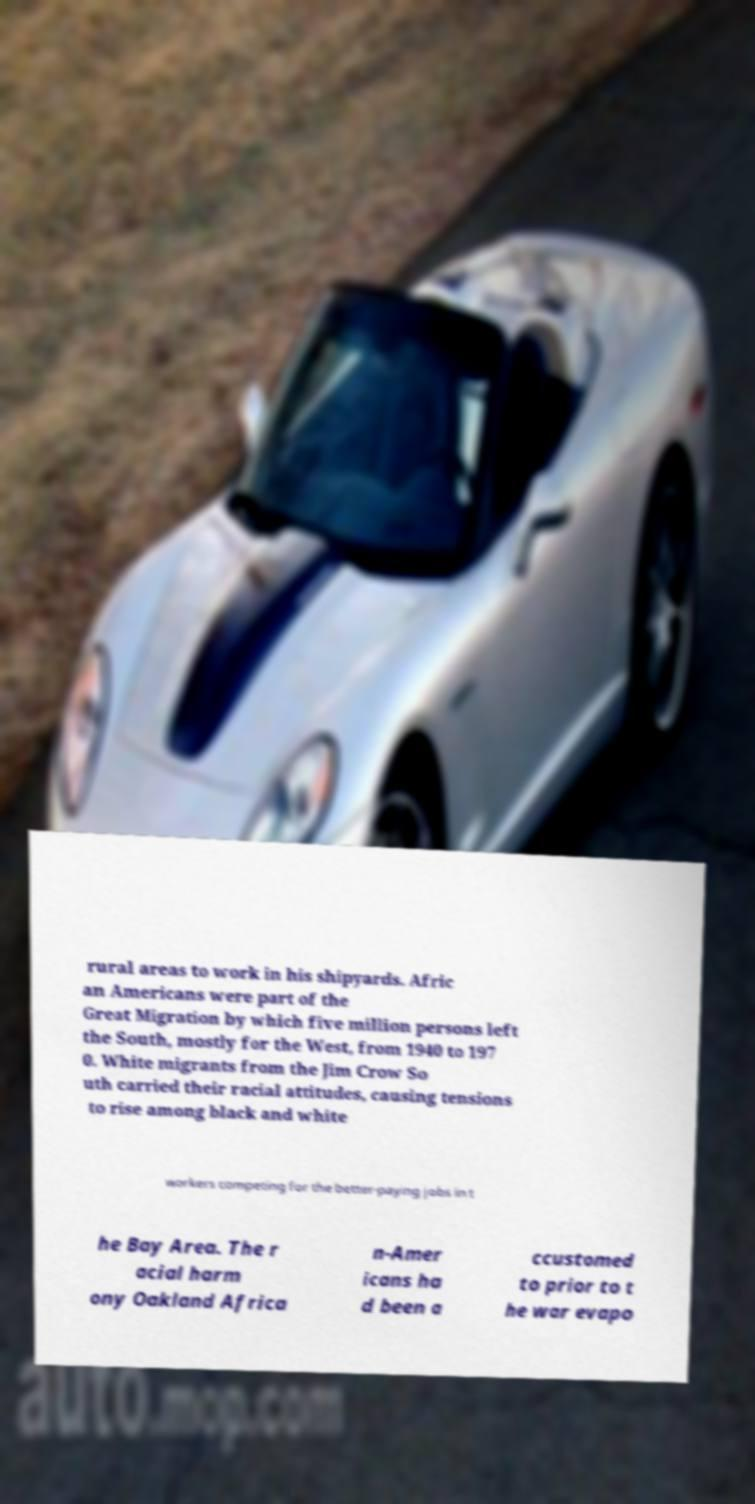I need the written content from this picture converted into text. Can you do that? rural areas to work in his shipyards. Afric an Americans were part of the Great Migration by which five million persons left the South, mostly for the West, from 1940 to 197 0. White migrants from the Jim Crow So uth carried their racial attitudes, causing tensions to rise among black and white workers competing for the better-paying jobs in t he Bay Area. The r acial harm ony Oakland Africa n-Amer icans ha d been a ccustomed to prior to t he war evapo 